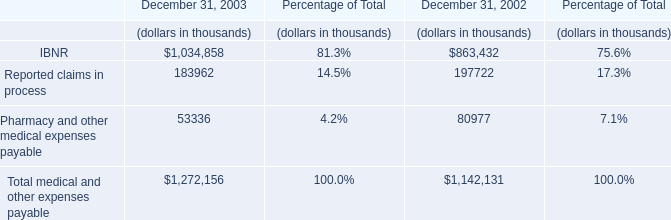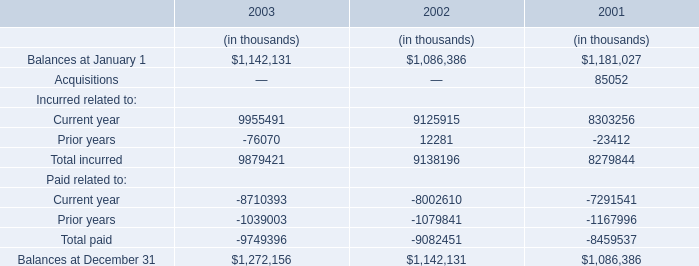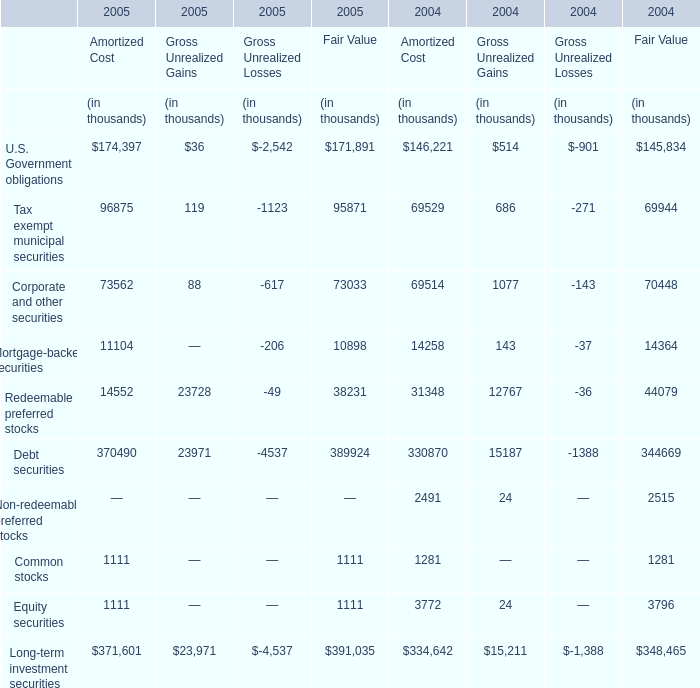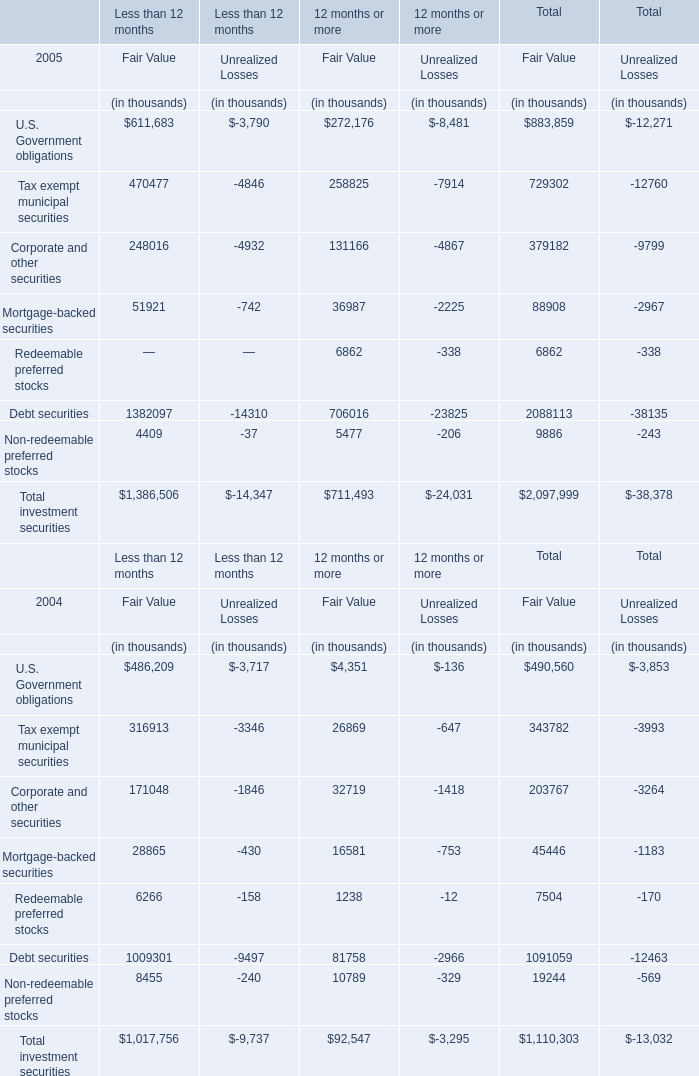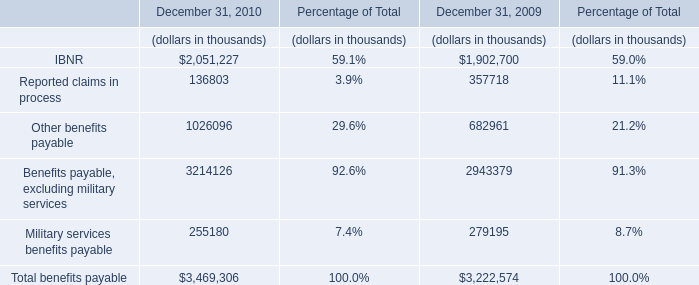Which year is Gross Unrealized Losses for Mortgage-backed securities lower? 
Answer: 2005. 